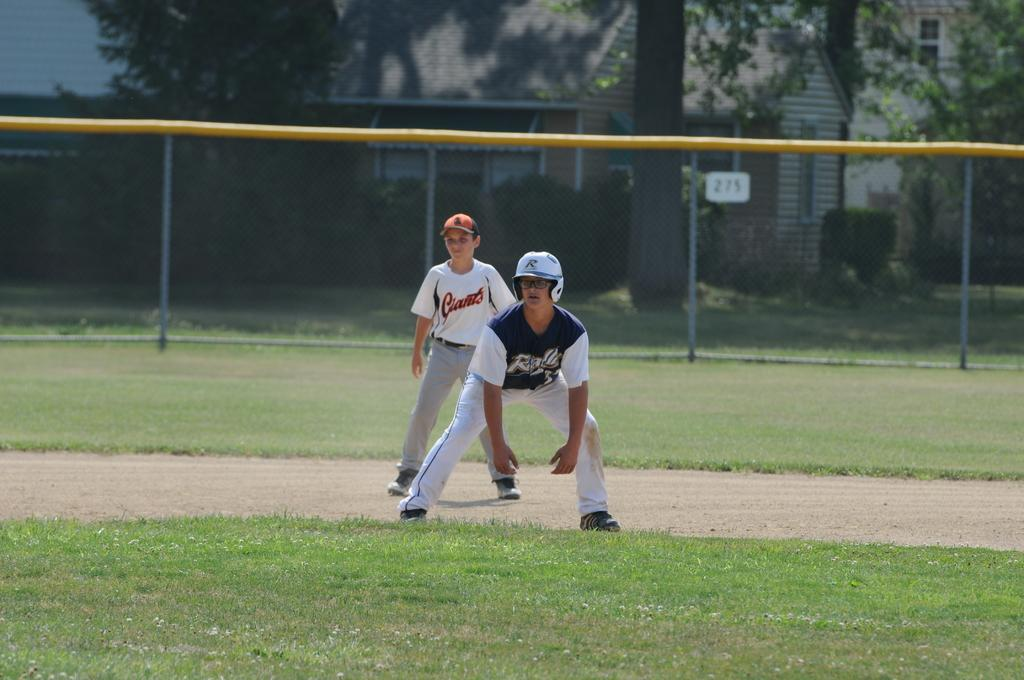Provide a one-sentence caption for the provided image. a boy in a Giants jersey stands behind another baseball player on a base. 